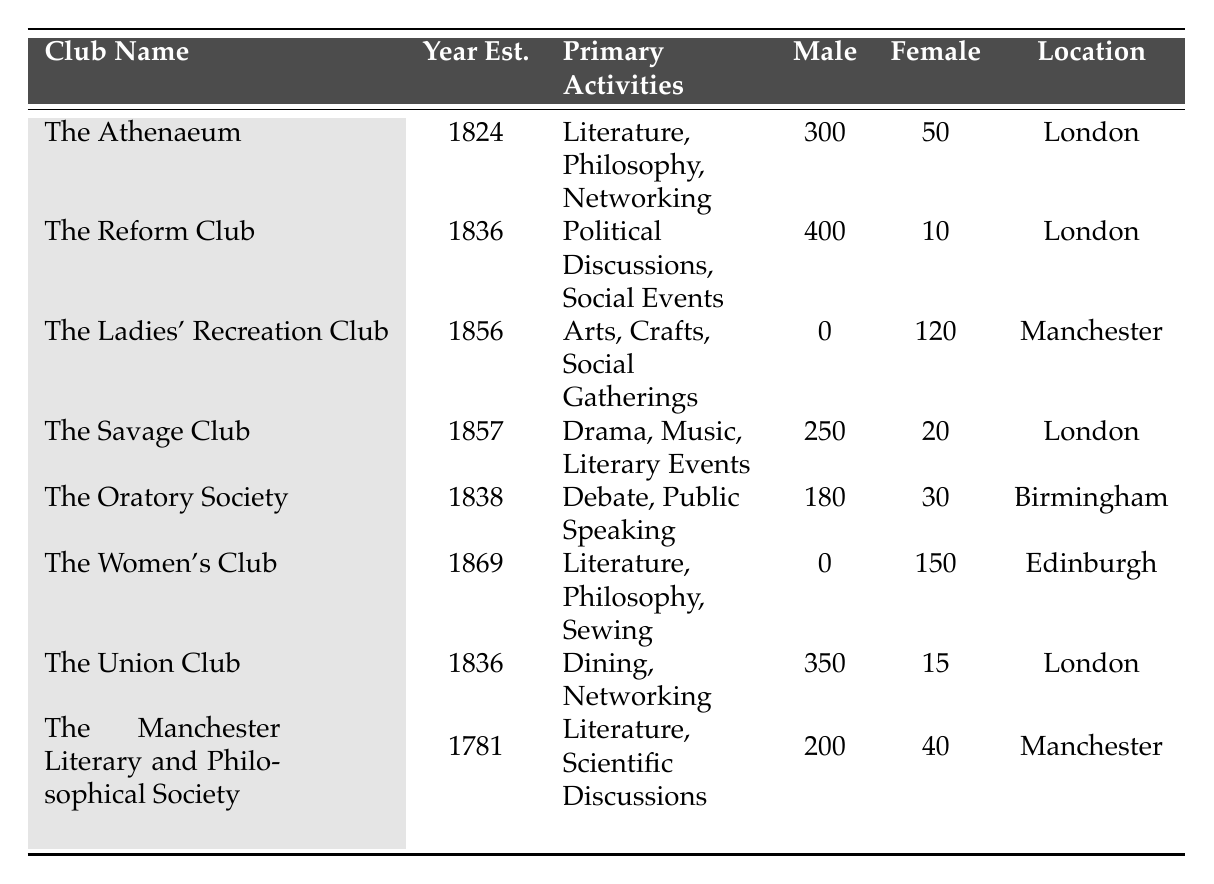What is the total number of members in The Ladies' Recreation Club? The table shows that The Ladies' Recreation Club has 0 male members and 120 female members. Adding them together gives 0 + 120 = 120 members total.
Answer: 120 Which club has the highest number of male members? By comparing the values in the "Male Members" column, The Reform Club has 400 male members, which is the highest among all listed clubs.
Answer: The Reform Club Does The Women's Club have any male members? The Gender Composition for The Women's Club shows 0 male members, indicating that no males are part of this club.
Answer: No What is the difference in female membership between The Athenaeum and The Savage Club? The Athenaeum has 50 female members and The Savage Club has 20 female members. The difference is calculated as 50 - 20 = 30.
Answer: 30 How many clubs have more female members than male members? The Ladies' Recreation Club and The Women's Club both have more female members (120 and 150, respectively) compared to their male members (0 each). Therefore, there are 2 clubs that meet this criterion.
Answer: 2 What is the average number of male members across all clubs? To find the average number of male members, sum all male members (300 + 400 + 0 + 250 + 180 + 0 + 350 + 200 = 1680) and divide by the number of clubs (8). The average is 1680/8 = 210.
Answer: 210 Which location has the greatest gender disparity in club membership? The Reform Club in London has the most significant disparity, with 400 male members and only 10 female members, leading to a disparity of 390.
Answer: London (The Reform Club) If you combined the female members of The Ladies' Recreation Club and The Women's Club, what would be the total? The Ladies' Recreation Club has 120 female members, and The Women's Club has 150. Adding these values gives 120 + 150 = 270 female members combined.
Answer: 270 How many clubs were established after 1850? From the table, The Ladies' Recreation Club, The Savage Club, and The Women's Club were established after 1850, making a total of 3 clubs.
Answer: 3 What percentage of the total members in The Union Club are female? The Union Club has 350 male and 15 female members, totalling 350 + 15 = 365. The percentage of female members is (15/365) x 100 ≈ 4.11%.
Answer: Approximately 4.11% 